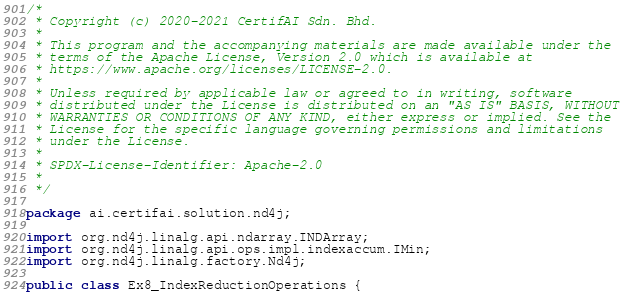<code> <loc_0><loc_0><loc_500><loc_500><_Java_>/*
 * Copyright (c) 2020-2021 CertifAI Sdn. Bhd.
 *
 * This program and the accompanying materials are made available under the
 * terms of the Apache License, Version 2.0 which is available at
 * https://www.apache.org/licenses/LICENSE-2.0.
 *
 * Unless required by applicable law or agreed to in writing, software
 * distributed under the License is distributed on an "AS IS" BASIS, WITHOUT
 * WARRANTIES OR CONDITIONS OF ANY KIND, either express or implied. See the
 * License for the specific language governing permissions and limitations
 * under the License.
 *
 * SPDX-License-Identifier: Apache-2.0
 *
 */

package ai.certifai.solution.nd4j;

import org.nd4j.linalg.api.ndarray.INDArray;
import org.nd4j.linalg.api.ops.impl.indexaccum.IMin;
import org.nd4j.linalg.factory.Nd4j;

public class Ex8_IndexReductionOperations {</code> 